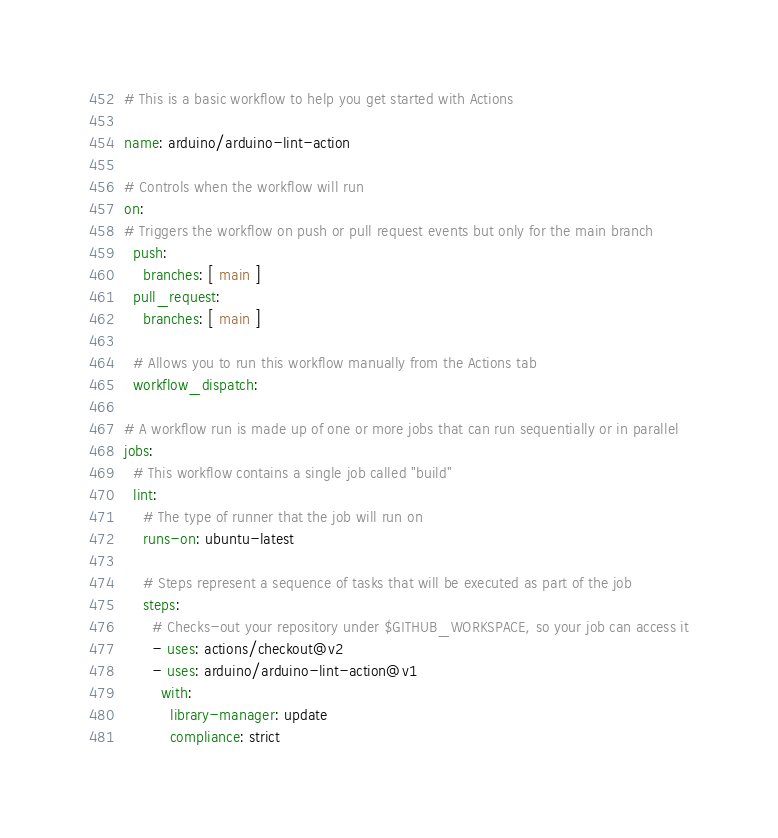<code> <loc_0><loc_0><loc_500><loc_500><_YAML_># This is a basic workflow to help you get started with Actions

name: arduino/arduino-lint-action

# Controls when the workflow will run
on:
# Triggers the workflow on push or pull request events but only for the main branch
  push:
    branches: [ main ]
  pull_request:
    branches: [ main ]

  # Allows you to run this workflow manually from the Actions tab
  workflow_dispatch:

# A workflow run is made up of one or more jobs that can run sequentially or in parallel
jobs:
  # This workflow contains a single job called "build"
  lint:
    # The type of runner that the job will run on
    runs-on: ubuntu-latest

    # Steps represent a sequence of tasks that will be executed as part of the job
    steps:
      # Checks-out your repository under $GITHUB_WORKSPACE, so your job can access it
      - uses: actions/checkout@v2
      - uses: arduino/arduino-lint-action@v1
        with:
          library-manager: update
          compliance: strict
</code> 